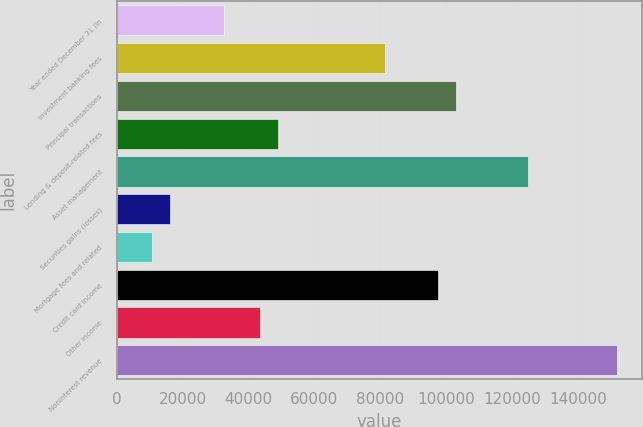Convert chart. <chart><loc_0><loc_0><loc_500><loc_500><bar_chart><fcel>Year ended December 31 (in<fcel>Investment banking fees<fcel>Principal transactions<fcel>Lending & deposit-related fees<fcel>Asset management<fcel>Securities gains (losses)<fcel>Mortgage fees and related<fcel>Credit card income<fcel>Other income<fcel>Noninterest revenue<nl><fcel>32549.3<fcel>81371.3<fcel>103070<fcel>48823.3<fcel>124769<fcel>16275.3<fcel>10850.7<fcel>97645.2<fcel>43398.6<fcel>151892<nl></chart> 